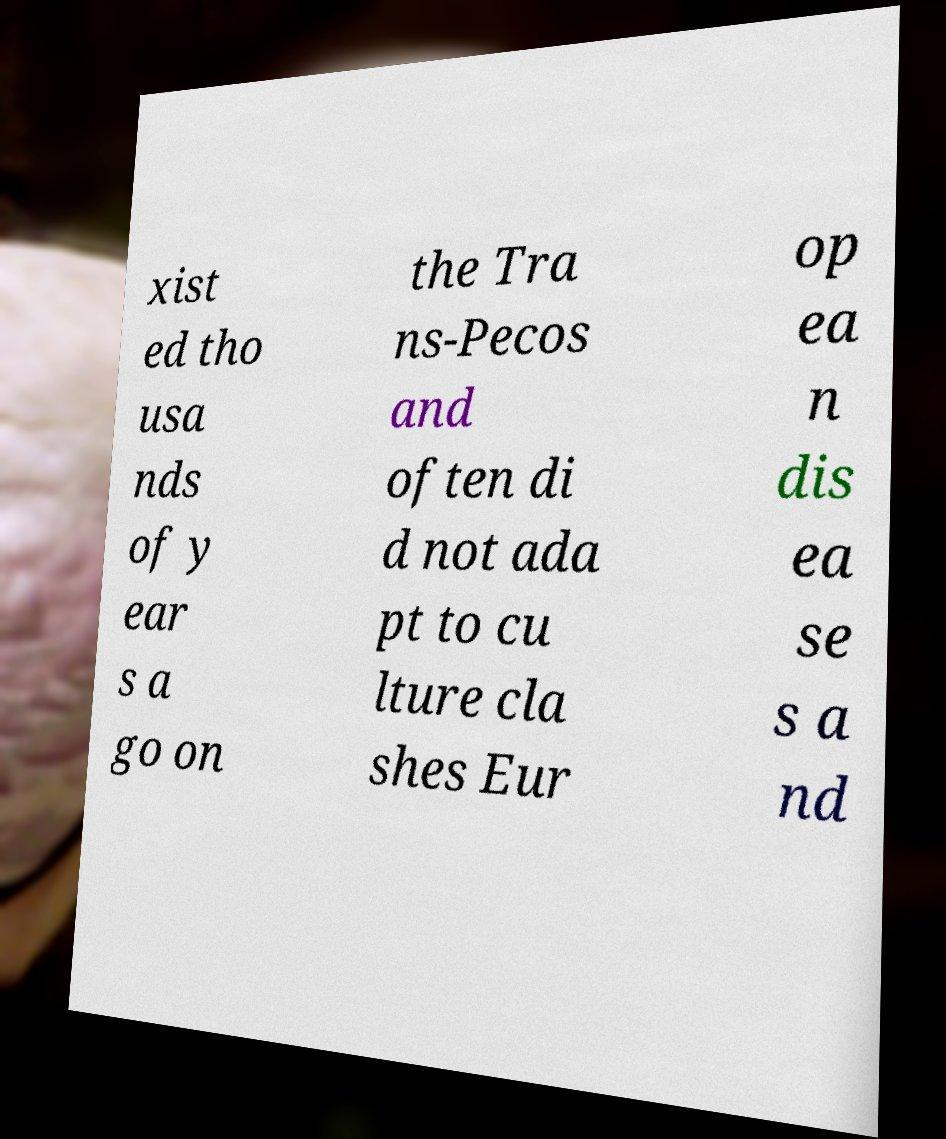There's text embedded in this image that I need extracted. Can you transcribe it verbatim? xist ed tho usa nds of y ear s a go on the Tra ns-Pecos and often di d not ada pt to cu lture cla shes Eur op ea n dis ea se s a nd 